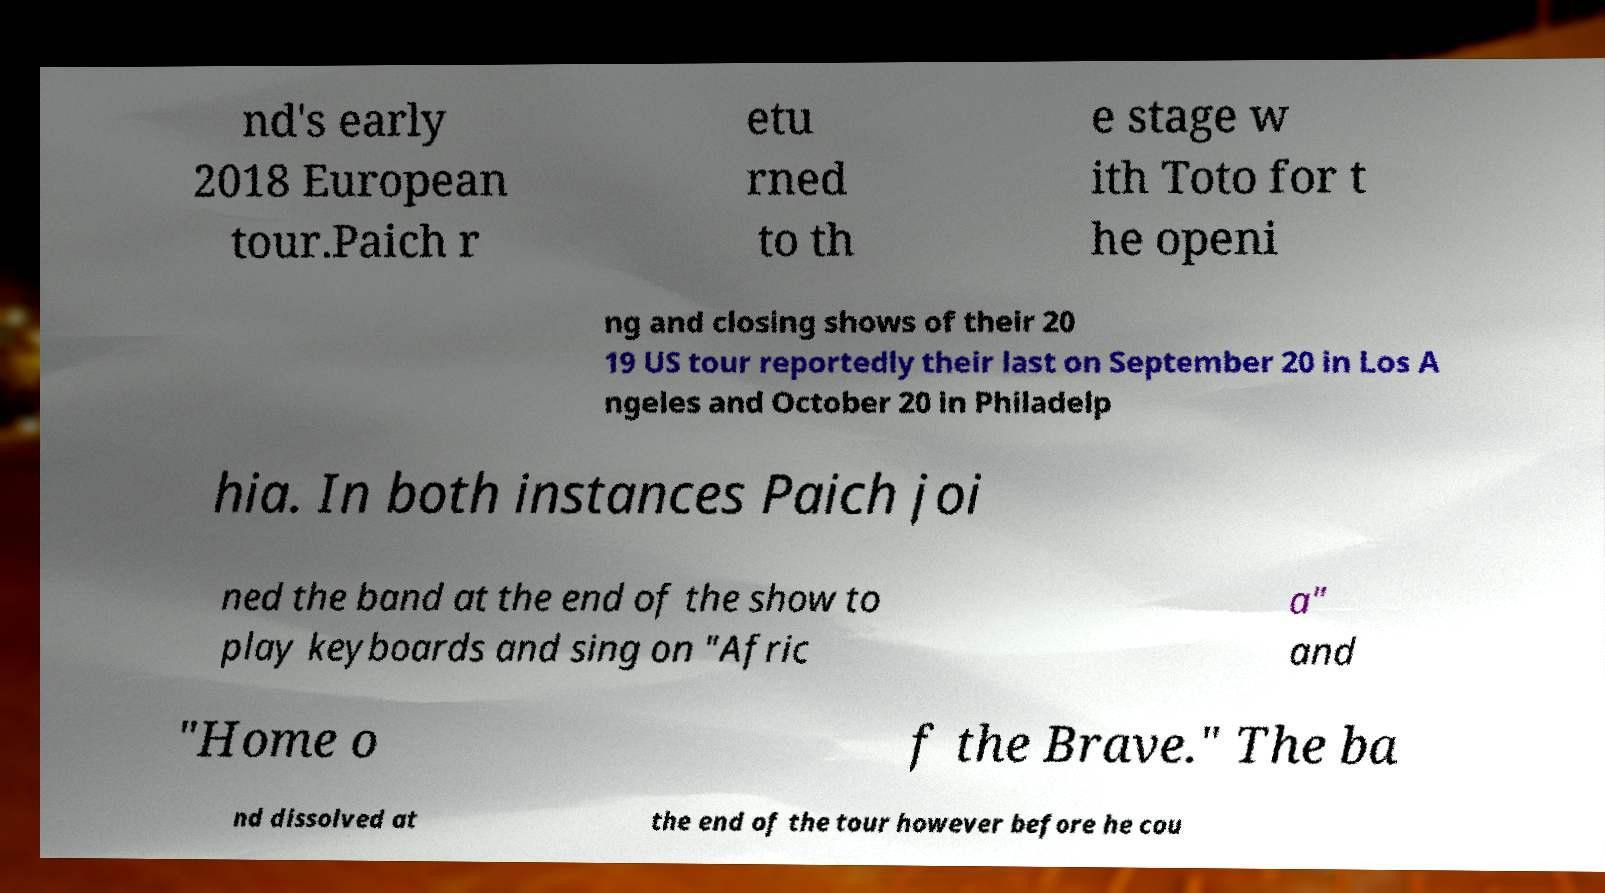For documentation purposes, I need the text within this image transcribed. Could you provide that? nd's early 2018 European tour.Paich r etu rned to th e stage w ith Toto for t he openi ng and closing shows of their 20 19 US tour reportedly their last on September 20 in Los A ngeles and October 20 in Philadelp hia. In both instances Paich joi ned the band at the end of the show to play keyboards and sing on "Afric a" and "Home o f the Brave." The ba nd dissolved at the end of the tour however before he cou 